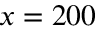Convert formula to latex. <formula><loc_0><loc_0><loc_500><loc_500>x = 2 0 0</formula> 